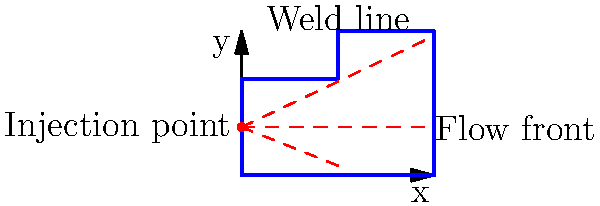In the mold flow analysis of the complex injection-molded part shown above, a weld line is observed near the top of the cavity. What primary factor contributes to the formation of this weld line, and how might it affect the mechanical properties of the final part? To understand the formation of the weld line and its effects, let's break down the analysis:

1. Weld line formation:
   a. The complex geometry of the part creates multiple flow paths.
   b. As the plastic melt flows from the injection point, it splits around the central protrusion.
   c. The separated flow fronts meet again at the top of the cavity, forming a weld line.

2. Primary factor contributing to weld line formation:
   The main factor is the presence of the central protrusion in the part geometry, which causes the melt flow to split and rejoin.

3. Effects on mechanical properties:
   a. Weld lines are typically weaker than the surrounding material due to:
      - Incomplete molecular entanglement at the meeting point of flow fronts
      - Potential alignment of filler particles or polymer chains parallel to the weld line
      - Possible entrapped air or contaminants
   b. This can lead to:
      - Reduced tensile strength (up to 10-20% lower than the base material)
      - Lower impact resistance
      - Potential crack initiation point under stress

4. Mitigation strategies:
   a. Optimize injection parameters (temperature, pressure, speed) to improve bonding at the weld line
   b. Consider relocating the injection point to minimize weld line formation in critical areas
   c. Modify part geometry to reduce flow obstacles, if possible
   d. Use mold temperature control to maintain uniform cooling

5. Importance in plastics engineering:
   Understanding and managing weld lines is crucial for ensuring the quality and performance of injection-molded parts, especially in applications where high strength and durability are required.
Answer: The central protrusion causes flow separation and rejoining, forming a weld line that can reduce mechanical strength. 